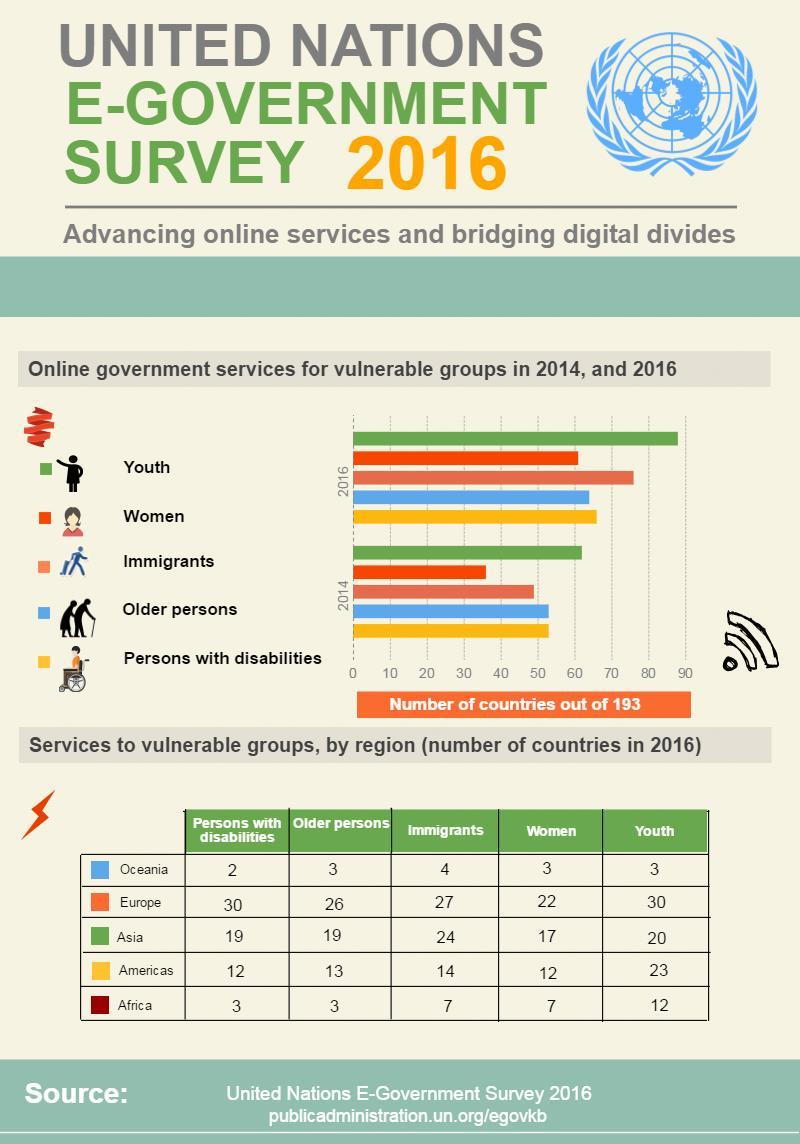Which region provides the lowest total number services to vulnerable groups?
Answer the question with a short phrase. Oceania What was the increase in online government services for women from 2014 to 2016? 26 Which region has the highest number of services provides to vulnerable groups? Europe Which vulnerable group has the second highest number of online services in 2016? Immigrants What is the difference in the number of online services provided for youth by Americas and Asia? 3 What is the total number of services provided to vulnerable groups in Americas? 74 Which vulnerable groups shows the same level of online government services in 2014? Older Persons, Persons with disabilities What is the total number of online services provided for youth in 2016 in all regions? 88 What is the difference in the number of online service provided for persons with disabilities by Europe and Oceania? 28 Which vulnerable group had the second lowest number of online services in 2014? Immigrants 